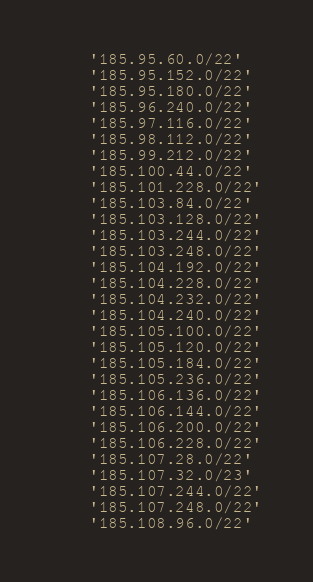Convert code to text. <code><loc_0><loc_0><loc_500><loc_500><_Bash_>    '185.95.60.0/22'
    '185.95.152.0/22'
    '185.95.180.0/22'
    '185.96.240.0/22'
    '185.97.116.0/22'
    '185.98.112.0/22'
    '185.99.212.0/22'
    '185.100.44.0/22'
    '185.101.228.0/22'
    '185.103.84.0/22'
    '185.103.128.0/22'
    '185.103.244.0/22'
    '185.103.248.0/22'
    '185.104.192.0/22'
    '185.104.228.0/22'
    '185.104.232.0/22'
    '185.104.240.0/22'
    '185.105.100.0/22'
    '185.105.120.0/22'
    '185.105.184.0/22'
    '185.105.236.0/22'
    '185.106.136.0/22'
    '185.106.144.0/22'
    '185.106.200.0/22'
    '185.106.228.0/22'
    '185.107.28.0/22'
    '185.107.32.0/23'
    '185.107.244.0/22'
    '185.107.248.0/22'
    '185.108.96.0/22'</code> 